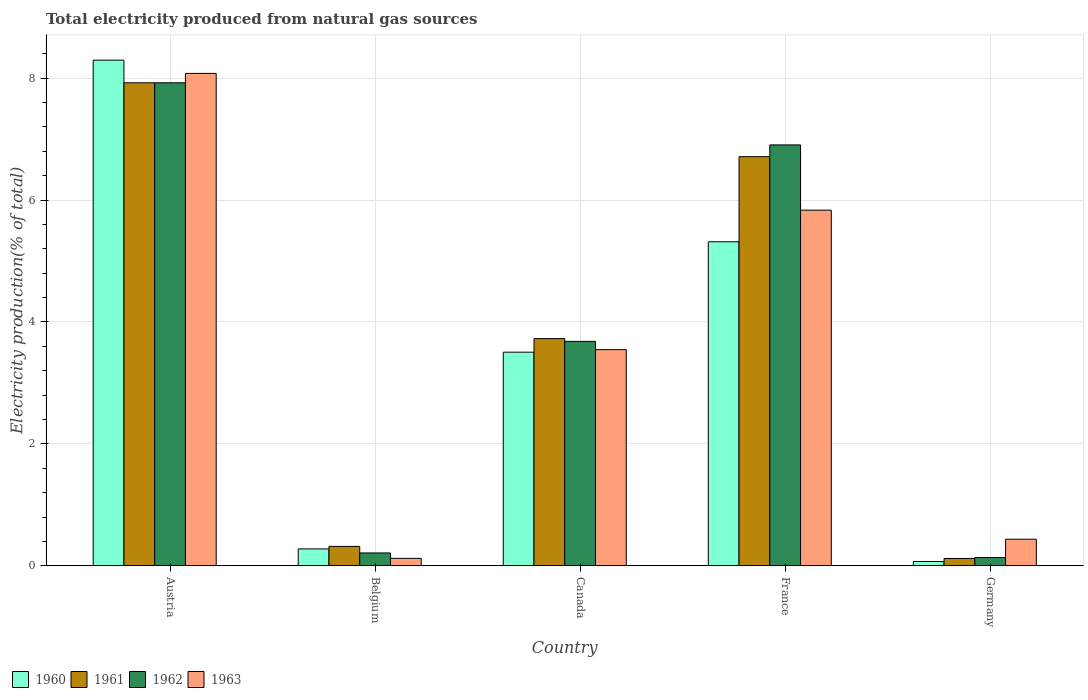How many groups of bars are there?
Offer a terse response. 5. Are the number of bars on each tick of the X-axis equal?
Offer a terse response. Yes. What is the label of the 4th group of bars from the left?
Your response must be concise. France. What is the total electricity produced in 1962 in Austria?
Your response must be concise. 7.92. Across all countries, what is the maximum total electricity produced in 1961?
Offer a terse response. 7.92. Across all countries, what is the minimum total electricity produced in 1962?
Your answer should be very brief. 0.14. In which country was the total electricity produced in 1961 minimum?
Offer a very short reply. Germany. What is the total total electricity produced in 1963 in the graph?
Provide a short and direct response. 18.02. What is the difference between the total electricity produced in 1963 in Canada and that in Germany?
Keep it short and to the point. 3.11. What is the difference between the total electricity produced in 1963 in Austria and the total electricity produced in 1960 in Canada?
Your answer should be compact. 4.57. What is the average total electricity produced in 1961 per country?
Make the answer very short. 3.76. What is the difference between the total electricity produced of/in 1963 and total electricity produced of/in 1962 in Austria?
Give a very brief answer. 0.15. In how many countries, is the total electricity produced in 1962 greater than 3.2 %?
Ensure brevity in your answer.  3. What is the ratio of the total electricity produced in 1961 in France to that in Germany?
Offer a terse response. 55.79. Is the total electricity produced in 1962 in Canada less than that in Germany?
Give a very brief answer. No. Is the difference between the total electricity produced in 1963 in Austria and Belgium greater than the difference between the total electricity produced in 1962 in Austria and Belgium?
Keep it short and to the point. Yes. What is the difference between the highest and the second highest total electricity produced in 1962?
Your answer should be very brief. -3.22. What is the difference between the highest and the lowest total electricity produced in 1961?
Provide a succinct answer. 7.8. In how many countries, is the total electricity produced in 1962 greater than the average total electricity produced in 1962 taken over all countries?
Provide a succinct answer. 2. Is it the case that in every country, the sum of the total electricity produced in 1961 and total electricity produced in 1963 is greater than the sum of total electricity produced in 1962 and total electricity produced in 1960?
Provide a succinct answer. No. Is it the case that in every country, the sum of the total electricity produced in 1961 and total electricity produced in 1960 is greater than the total electricity produced in 1963?
Provide a succinct answer. No. How many bars are there?
Offer a very short reply. 20. How many countries are there in the graph?
Make the answer very short. 5. Are the values on the major ticks of Y-axis written in scientific E-notation?
Offer a very short reply. No. Does the graph contain any zero values?
Ensure brevity in your answer.  No. How many legend labels are there?
Make the answer very short. 4. How are the legend labels stacked?
Your answer should be compact. Horizontal. What is the title of the graph?
Ensure brevity in your answer.  Total electricity produced from natural gas sources. Does "1986" appear as one of the legend labels in the graph?
Your answer should be very brief. No. What is the label or title of the Y-axis?
Make the answer very short. Electricity production(% of total). What is the Electricity production(% of total) in 1960 in Austria?
Keep it short and to the point. 8.3. What is the Electricity production(% of total) of 1961 in Austria?
Give a very brief answer. 7.92. What is the Electricity production(% of total) of 1962 in Austria?
Offer a very short reply. 7.92. What is the Electricity production(% of total) in 1963 in Austria?
Provide a succinct answer. 8.08. What is the Electricity production(% of total) of 1960 in Belgium?
Make the answer very short. 0.28. What is the Electricity production(% of total) of 1961 in Belgium?
Provide a short and direct response. 0.32. What is the Electricity production(% of total) in 1962 in Belgium?
Give a very brief answer. 0.21. What is the Electricity production(% of total) of 1963 in Belgium?
Your answer should be very brief. 0.12. What is the Electricity production(% of total) in 1960 in Canada?
Make the answer very short. 3.5. What is the Electricity production(% of total) of 1961 in Canada?
Offer a very short reply. 3.73. What is the Electricity production(% of total) in 1962 in Canada?
Make the answer very short. 3.68. What is the Electricity production(% of total) in 1963 in Canada?
Your response must be concise. 3.55. What is the Electricity production(% of total) of 1960 in France?
Your response must be concise. 5.32. What is the Electricity production(% of total) of 1961 in France?
Your response must be concise. 6.71. What is the Electricity production(% of total) of 1962 in France?
Give a very brief answer. 6.91. What is the Electricity production(% of total) in 1963 in France?
Your answer should be compact. 5.83. What is the Electricity production(% of total) of 1960 in Germany?
Your response must be concise. 0.07. What is the Electricity production(% of total) of 1961 in Germany?
Keep it short and to the point. 0.12. What is the Electricity production(% of total) in 1962 in Germany?
Your answer should be compact. 0.14. What is the Electricity production(% of total) of 1963 in Germany?
Make the answer very short. 0.44. Across all countries, what is the maximum Electricity production(% of total) of 1960?
Make the answer very short. 8.3. Across all countries, what is the maximum Electricity production(% of total) of 1961?
Provide a succinct answer. 7.92. Across all countries, what is the maximum Electricity production(% of total) of 1962?
Provide a succinct answer. 7.92. Across all countries, what is the maximum Electricity production(% of total) in 1963?
Your answer should be compact. 8.08. Across all countries, what is the minimum Electricity production(% of total) in 1960?
Provide a succinct answer. 0.07. Across all countries, what is the minimum Electricity production(% of total) of 1961?
Your response must be concise. 0.12. Across all countries, what is the minimum Electricity production(% of total) of 1962?
Keep it short and to the point. 0.14. Across all countries, what is the minimum Electricity production(% of total) in 1963?
Keep it short and to the point. 0.12. What is the total Electricity production(% of total) in 1960 in the graph?
Ensure brevity in your answer.  17.46. What is the total Electricity production(% of total) of 1961 in the graph?
Provide a short and direct response. 18.8. What is the total Electricity production(% of total) in 1962 in the graph?
Provide a short and direct response. 18.86. What is the total Electricity production(% of total) of 1963 in the graph?
Offer a terse response. 18.02. What is the difference between the Electricity production(% of total) in 1960 in Austria and that in Belgium?
Provide a succinct answer. 8.02. What is the difference between the Electricity production(% of total) of 1961 in Austria and that in Belgium?
Your answer should be very brief. 7.61. What is the difference between the Electricity production(% of total) in 1962 in Austria and that in Belgium?
Your response must be concise. 7.71. What is the difference between the Electricity production(% of total) in 1963 in Austria and that in Belgium?
Provide a short and direct response. 7.96. What is the difference between the Electricity production(% of total) in 1960 in Austria and that in Canada?
Keep it short and to the point. 4.79. What is the difference between the Electricity production(% of total) of 1961 in Austria and that in Canada?
Make the answer very short. 4.2. What is the difference between the Electricity production(% of total) of 1962 in Austria and that in Canada?
Your answer should be compact. 4.24. What is the difference between the Electricity production(% of total) of 1963 in Austria and that in Canada?
Your answer should be very brief. 4.53. What is the difference between the Electricity production(% of total) of 1960 in Austria and that in France?
Make the answer very short. 2.98. What is the difference between the Electricity production(% of total) in 1961 in Austria and that in France?
Offer a very short reply. 1.21. What is the difference between the Electricity production(% of total) in 1962 in Austria and that in France?
Make the answer very short. 1.02. What is the difference between the Electricity production(% of total) of 1963 in Austria and that in France?
Provide a succinct answer. 2.24. What is the difference between the Electricity production(% of total) of 1960 in Austria and that in Germany?
Provide a succinct answer. 8.23. What is the difference between the Electricity production(% of total) of 1961 in Austria and that in Germany?
Your answer should be very brief. 7.8. What is the difference between the Electricity production(% of total) in 1962 in Austria and that in Germany?
Offer a very short reply. 7.79. What is the difference between the Electricity production(% of total) of 1963 in Austria and that in Germany?
Keep it short and to the point. 7.64. What is the difference between the Electricity production(% of total) of 1960 in Belgium and that in Canada?
Make the answer very short. -3.23. What is the difference between the Electricity production(% of total) of 1961 in Belgium and that in Canada?
Give a very brief answer. -3.41. What is the difference between the Electricity production(% of total) of 1962 in Belgium and that in Canada?
Keep it short and to the point. -3.47. What is the difference between the Electricity production(% of total) in 1963 in Belgium and that in Canada?
Ensure brevity in your answer.  -3.42. What is the difference between the Electricity production(% of total) of 1960 in Belgium and that in France?
Give a very brief answer. -5.04. What is the difference between the Electricity production(% of total) of 1961 in Belgium and that in France?
Give a very brief answer. -6.39. What is the difference between the Electricity production(% of total) in 1962 in Belgium and that in France?
Offer a terse response. -6.69. What is the difference between the Electricity production(% of total) of 1963 in Belgium and that in France?
Provide a short and direct response. -5.71. What is the difference between the Electricity production(% of total) in 1960 in Belgium and that in Germany?
Offer a terse response. 0.21. What is the difference between the Electricity production(% of total) of 1961 in Belgium and that in Germany?
Keep it short and to the point. 0.2. What is the difference between the Electricity production(% of total) in 1962 in Belgium and that in Germany?
Your answer should be compact. 0.07. What is the difference between the Electricity production(% of total) of 1963 in Belgium and that in Germany?
Your answer should be very brief. -0.31. What is the difference between the Electricity production(% of total) in 1960 in Canada and that in France?
Your answer should be compact. -1.81. What is the difference between the Electricity production(% of total) in 1961 in Canada and that in France?
Your response must be concise. -2.99. What is the difference between the Electricity production(% of total) of 1962 in Canada and that in France?
Provide a short and direct response. -3.22. What is the difference between the Electricity production(% of total) in 1963 in Canada and that in France?
Keep it short and to the point. -2.29. What is the difference between the Electricity production(% of total) of 1960 in Canada and that in Germany?
Your answer should be compact. 3.43. What is the difference between the Electricity production(% of total) in 1961 in Canada and that in Germany?
Give a very brief answer. 3.61. What is the difference between the Electricity production(% of total) of 1962 in Canada and that in Germany?
Keep it short and to the point. 3.55. What is the difference between the Electricity production(% of total) of 1963 in Canada and that in Germany?
Your response must be concise. 3.11. What is the difference between the Electricity production(% of total) in 1960 in France and that in Germany?
Offer a very short reply. 5.25. What is the difference between the Electricity production(% of total) in 1961 in France and that in Germany?
Give a very brief answer. 6.59. What is the difference between the Electricity production(% of total) of 1962 in France and that in Germany?
Your answer should be compact. 6.77. What is the difference between the Electricity production(% of total) in 1963 in France and that in Germany?
Offer a terse response. 5.4. What is the difference between the Electricity production(% of total) of 1960 in Austria and the Electricity production(% of total) of 1961 in Belgium?
Your answer should be compact. 7.98. What is the difference between the Electricity production(% of total) in 1960 in Austria and the Electricity production(% of total) in 1962 in Belgium?
Your answer should be very brief. 8.08. What is the difference between the Electricity production(% of total) in 1960 in Austria and the Electricity production(% of total) in 1963 in Belgium?
Your answer should be very brief. 8.17. What is the difference between the Electricity production(% of total) of 1961 in Austria and the Electricity production(% of total) of 1962 in Belgium?
Your answer should be very brief. 7.71. What is the difference between the Electricity production(% of total) of 1961 in Austria and the Electricity production(% of total) of 1963 in Belgium?
Ensure brevity in your answer.  7.8. What is the difference between the Electricity production(% of total) of 1962 in Austria and the Electricity production(% of total) of 1963 in Belgium?
Your response must be concise. 7.8. What is the difference between the Electricity production(% of total) of 1960 in Austria and the Electricity production(% of total) of 1961 in Canada?
Give a very brief answer. 4.57. What is the difference between the Electricity production(% of total) of 1960 in Austria and the Electricity production(% of total) of 1962 in Canada?
Ensure brevity in your answer.  4.61. What is the difference between the Electricity production(% of total) of 1960 in Austria and the Electricity production(% of total) of 1963 in Canada?
Your answer should be very brief. 4.75. What is the difference between the Electricity production(% of total) of 1961 in Austria and the Electricity production(% of total) of 1962 in Canada?
Ensure brevity in your answer.  4.24. What is the difference between the Electricity production(% of total) in 1961 in Austria and the Electricity production(% of total) in 1963 in Canada?
Your answer should be compact. 4.38. What is the difference between the Electricity production(% of total) of 1962 in Austria and the Electricity production(% of total) of 1963 in Canada?
Your answer should be compact. 4.38. What is the difference between the Electricity production(% of total) in 1960 in Austria and the Electricity production(% of total) in 1961 in France?
Your answer should be very brief. 1.58. What is the difference between the Electricity production(% of total) of 1960 in Austria and the Electricity production(% of total) of 1962 in France?
Offer a terse response. 1.39. What is the difference between the Electricity production(% of total) in 1960 in Austria and the Electricity production(% of total) in 1963 in France?
Make the answer very short. 2.46. What is the difference between the Electricity production(% of total) in 1961 in Austria and the Electricity production(% of total) in 1963 in France?
Offer a very short reply. 2.09. What is the difference between the Electricity production(% of total) of 1962 in Austria and the Electricity production(% of total) of 1963 in France?
Your response must be concise. 2.09. What is the difference between the Electricity production(% of total) in 1960 in Austria and the Electricity production(% of total) in 1961 in Germany?
Provide a succinct answer. 8.18. What is the difference between the Electricity production(% of total) in 1960 in Austria and the Electricity production(% of total) in 1962 in Germany?
Your response must be concise. 8.16. What is the difference between the Electricity production(% of total) of 1960 in Austria and the Electricity production(% of total) of 1963 in Germany?
Offer a very short reply. 7.86. What is the difference between the Electricity production(% of total) of 1961 in Austria and the Electricity production(% of total) of 1962 in Germany?
Your answer should be very brief. 7.79. What is the difference between the Electricity production(% of total) of 1961 in Austria and the Electricity production(% of total) of 1963 in Germany?
Your answer should be compact. 7.49. What is the difference between the Electricity production(% of total) in 1962 in Austria and the Electricity production(% of total) in 1963 in Germany?
Provide a succinct answer. 7.49. What is the difference between the Electricity production(% of total) of 1960 in Belgium and the Electricity production(% of total) of 1961 in Canada?
Your answer should be very brief. -3.45. What is the difference between the Electricity production(% of total) of 1960 in Belgium and the Electricity production(% of total) of 1962 in Canada?
Keep it short and to the point. -3.4. What is the difference between the Electricity production(% of total) of 1960 in Belgium and the Electricity production(% of total) of 1963 in Canada?
Ensure brevity in your answer.  -3.27. What is the difference between the Electricity production(% of total) in 1961 in Belgium and the Electricity production(% of total) in 1962 in Canada?
Offer a very short reply. -3.36. What is the difference between the Electricity production(% of total) in 1961 in Belgium and the Electricity production(% of total) in 1963 in Canada?
Give a very brief answer. -3.23. What is the difference between the Electricity production(% of total) in 1962 in Belgium and the Electricity production(% of total) in 1963 in Canada?
Give a very brief answer. -3.34. What is the difference between the Electricity production(% of total) of 1960 in Belgium and the Electricity production(% of total) of 1961 in France?
Ensure brevity in your answer.  -6.43. What is the difference between the Electricity production(% of total) in 1960 in Belgium and the Electricity production(% of total) in 1962 in France?
Offer a terse response. -6.63. What is the difference between the Electricity production(% of total) of 1960 in Belgium and the Electricity production(% of total) of 1963 in France?
Your answer should be compact. -5.56. What is the difference between the Electricity production(% of total) in 1961 in Belgium and the Electricity production(% of total) in 1962 in France?
Offer a very short reply. -6.59. What is the difference between the Electricity production(% of total) in 1961 in Belgium and the Electricity production(% of total) in 1963 in France?
Give a very brief answer. -5.52. What is the difference between the Electricity production(% of total) in 1962 in Belgium and the Electricity production(% of total) in 1963 in France?
Provide a short and direct response. -5.62. What is the difference between the Electricity production(% of total) in 1960 in Belgium and the Electricity production(% of total) in 1961 in Germany?
Offer a terse response. 0.16. What is the difference between the Electricity production(% of total) of 1960 in Belgium and the Electricity production(% of total) of 1962 in Germany?
Provide a short and direct response. 0.14. What is the difference between the Electricity production(% of total) of 1960 in Belgium and the Electricity production(% of total) of 1963 in Germany?
Your answer should be very brief. -0.16. What is the difference between the Electricity production(% of total) of 1961 in Belgium and the Electricity production(% of total) of 1962 in Germany?
Keep it short and to the point. 0.18. What is the difference between the Electricity production(% of total) of 1961 in Belgium and the Electricity production(% of total) of 1963 in Germany?
Your response must be concise. -0.12. What is the difference between the Electricity production(% of total) of 1962 in Belgium and the Electricity production(% of total) of 1963 in Germany?
Ensure brevity in your answer.  -0.23. What is the difference between the Electricity production(% of total) of 1960 in Canada and the Electricity production(% of total) of 1961 in France?
Give a very brief answer. -3.21. What is the difference between the Electricity production(% of total) in 1960 in Canada and the Electricity production(% of total) in 1962 in France?
Provide a succinct answer. -3.4. What is the difference between the Electricity production(% of total) of 1960 in Canada and the Electricity production(% of total) of 1963 in France?
Give a very brief answer. -2.33. What is the difference between the Electricity production(% of total) in 1961 in Canada and the Electricity production(% of total) in 1962 in France?
Offer a very short reply. -3.18. What is the difference between the Electricity production(% of total) in 1961 in Canada and the Electricity production(% of total) in 1963 in France?
Your response must be concise. -2.11. What is the difference between the Electricity production(% of total) of 1962 in Canada and the Electricity production(% of total) of 1963 in France?
Provide a succinct answer. -2.15. What is the difference between the Electricity production(% of total) of 1960 in Canada and the Electricity production(% of total) of 1961 in Germany?
Provide a short and direct response. 3.38. What is the difference between the Electricity production(% of total) of 1960 in Canada and the Electricity production(% of total) of 1962 in Germany?
Your answer should be compact. 3.37. What is the difference between the Electricity production(% of total) in 1960 in Canada and the Electricity production(% of total) in 1963 in Germany?
Your response must be concise. 3.07. What is the difference between the Electricity production(% of total) of 1961 in Canada and the Electricity production(% of total) of 1962 in Germany?
Keep it short and to the point. 3.59. What is the difference between the Electricity production(% of total) of 1961 in Canada and the Electricity production(% of total) of 1963 in Germany?
Provide a succinct answer. 3.29. What is the difference between the Electricity production(% of total) in 1962 in Canada and the Electricity production(% of total) in 1963 in Germany?
Provide a succinct answer. 3.25. What is the difference between the Electricity production(% of total) of 1960 in France and the Electricity production(% of total) of 1961 in Germany?
Offer a terse response. 5.2. What is the difference between the Electricity production(% of total) of 1960 in France and the Electricity production(% of total) of 1962 in Germany?
Provide a short and direct response. 5.18. What is the difference between the Electricity production(% of total) of 1960 in France and the Electricity production(% of total) of 1963 in Germany?
Your response must be concise. 4.88. What is the difference between the Electricity production(% of total) in 1961 in France and the Electricity production(% of total) in 1962 in Germany?
Ensure brevity in your answer.  6.58. What is the difference between the Electricity production(% of total) in 1961 in France and the Electricity production(% of total) in 1963 in Germany?
Offer a terse response. 6.28. What is the difference between the Electricity production(% of total) in 1962 in France and the Electricity production(% of total) in 1963 in Germany?
Make the answer very short. 6.47. What is the average Electricity production(% of total) of 1960 per country?
Keep it short and to the point. 3.49. What is the average Electricity production(% of total) in 1961 per country?
Offer a terse response. 3.76. What is the average Electricity production(% of total) of 1962 per country?
Your answer should be compact. 3.77. What is the average Electricity production(% of total) of 1963 per country?
Offer a very short reply. 3.6. What is the difference between the Electricity production(% of total) in 1960 and Electricity production(% of total) in 1961 in Austria?
Provide a succinct answer. 0.37. What is the difference between the Electricity production(% of total) of 1960 and Electricity production(% of total) of 1962 in Austria?
Keep it short and to the point. 0.37. What is the difference between the Electricity production(% of total) of 1960 and Electricity production(% of total) of 1963 in Austria?
Ensure brevity in your answer.  0.22. What is the difference between the Electricity production(% of total) of 1961 and Electricity production(% of total) of 1963 in Austria?
Provide a succinct answer. -0.15. What is the difference between the Electricity production(% of total) in 1962 and Electricity production(% of total) in 1963 in Austria?
Provide a short and direct response. -0.15. What is the difference between the Electricity production(% of total) in 1960 and Electricity production(% of total) in 1961 in Belgium?
Your answer should be very brief. -0.04. What is the difference between the Electricity production(% of total) in 1960 and Electricity production(% of total) in 1962 in Belgium?
Give a very brief answer. 0.07. What is the difference between the Electricity production(% of total) of 1960 and Electricity production(% of total) of 1963 in Belgium?
Make the answer very short. 0.15. What is the difference between the Electricity production(% of total) of 1961 and Electricity production(% of total) of 1962 in Belgium?
Offer a terse response. 0.11. What is the difference between the Electricity production(% of total) of 1961 and Electricity production(% of total) of 1963 in Belgium?
Offer a terse response. 0.2. What is the difference between the Electricity production(% of total) in 1962 and Electricity production(% of total) in 1963 in Belgium?
Keep it short and to the point. 0.09. What is the difference between the Electricity production(% of total) of 1960 and Electricity production(% of total) of 1961 in Canada?
Give a very brief answer. -0.22. What is the difference between the Electricity production(% of total) of 1960 and Electricity production(% of total) of 1962 in Canada?
Offer a very short reply. -0.18. What is the difference between the Electricity production(% of total) of 1960 and Electricity production(% of total) of 1963 in Canada?
Your answer should be compact. -0.04. What is the difference between the Electricity production(% of total) in 1961 and Electricity production(% of total) in 1962 in Canada?
Make the answer very short. 0.05. What is the difference between the Electricity production(% of total) in 1961 and Electricity production(% of total) in 1963 in Canada?
Ensure brevity in your answer.  0.18. What is the difference between the Electricity production(% of total) in 1962 and Electricity production(% of total) in 1963 in Canada?
Offer a very short reply. 0.14. What is the difference between the Electricity production(% of total) in 1960 and Electricity production(% of total) in 1961 in France?
Provide a succinct answer. -1.4. What is the difference between the Electricity production(% of total) in 1960 and Electricity production(% of total) in 1962 in France?
Give a very brief answer. -1.59. What is the difference between the Electricity production(% of total) of 1960 and Electricity production(% of total) of 1963 in France?
Give a very brief answer. -0.52. What is the difference between the Electricity production(% of total) in 1961 and Electricity production(% of total) in 1962 in France?
Ensure brevity in your answer.  -0.19. What is the difference between the Electricity production(% of total) in 1961 and Electricity production(% of total) in 1963 in France?
Keep it short and to the point. 0.88. What is the difference between the Electricity production(% of total) of 1962 and Electricity production(% of total) of 1963 in France?
Your answer should be very brief. 1.07. What is the difference between the Electricity production(% of total) of 1960 and Electricity production(% of total) of 1962 in Germany?
Make the answer very short. -0.07. What is the difference between the Electricity production(% of total) of 1960 and Electricity production(% of total) of 1963 in Germany?
Ensure brevity in your answer.  -0.37. What is the difference between the Electricity production(% of total) of 1961 and Electricity production(% of total) of 1962 in Germany?
Make the answer very short. -0.02. What is the difference between the Electricity production(% of total) of 1961 and Electricity production(% of total) of 1963 in Germany?
Ensure brevity in your answer.  -0.32. What is the difference between the Electricity production(% of total) of 1962 and Electricity production(% of total) of 1963 in Germany?
Offer a terse response. -0.3. What is the ratio of the Electricity production(% of total) in 1960 in Austria to that in Belgium?
Keep it short and to the point. 29.93. What is the ratio of the Electricity production(% of total) of 1961 in Austria to that in Belgium?
Ensure brevity in your answer.  24.9. What is the ratio of the Electricity production(% of total) in 1962 in Austria to that in Belgium?
Your response must be concise. 37.57. What is the ratio of the Electricity production(% of total) of 1963 in Austria to that in Belgium?
Make the answer very short. 66.07. What is the ratio of the Electricity production(% of total) of 1960 in Austria to that in Canada?
Provide a short and direct response. 2.37. What is the ratio of the Electricity production(% of total) in 1961 in Austria to that in Canada?
Make the answer very short. 2.13. What is the ratio of the Electricity production(% of total) in 1962 in Austria to that in Canada?
Keep it short and to the point. 2.15. What is the ratio of the Electricity production(% of total) of 1963 in Austria to that in Canada?
Offer a terse response. 2.28. What is the ratio of the Electricity production(% of total) in 1960 in Austria to that in France?
Make the answer very short. 1.56. What is the ratio of the Electricity production(% of total) in 1961 in Austria to that in France?
Provide a short and direct response. 1.18. What is the ratio of the Electricity production(% of total) of 1962 in Austria to that in France?
Provide a short and direct response. 1.15. What is the ratio of the Electricity production(% of total) of 1963 in Austria to that in France?
Offer a very short reply. 1.38. What is the ratio of the Electricity production(% of total) of 1960 in Austria to that in Germany?
Offer a very short reply. 118.01. What is the ratio of the Electricity production(% of total) of 1961 in Austria to that in Germany?
Offer a very short reply. 65.86. What is the ratio of the Electricity production(% of total) in 1962 in Austria to that in Germany?
Give a very brief answer. 58.17. What is the ratio of the Electricity production(% of total) in 1963 in Austria to that in Germany?
Offer a very short reply. 18.52. What is the ratio of the Electricity production(% of total) in 1960 in Belgium to that in Canada?
Your answer should be very brief. 0.08. What is the ratio of the Electricity production(% of total) of 1961 in Belgium to that in Canada?
Your answer should be compact. 0.09. What is the ratio of the Electricity production(% of total) in 1962 in Belgium to that in Canada?
Provide a succinct answer. 0.06. What is the ratio of the Electricity production(% of total) in 1963 in Belgium to that in Canada?
Offer a very short reply. 0.03. What is the ratio of the Electricity production(% of total) of 1960 in Belgium to that in France?
Ensure brevity in your answer.  0.05. What is the ratio of the Electricity production(% of total) in 1961 in Belgium to that in France?
Your answer should be compact. 0.05. What is the ratio of the Electricity production(% of total) of 1962 in Belgium to that in France?
Your answer should be very brief. 0.03. What is the ratio of the Electricity production(% of total) of 1963 in Belgium to that in France?
Keep it short and to the point. 0.02. What is the ratio of the Electricity production(% of total) in 1960 in Belgium to that in Germany?
Your answer should be very brief. 3.94. What is the ratio of the Electricity production(% of total) of 1961 in Belgium to that in Germany?
Ensure brevity in your answer.  2.64. What is the ratio of the Electricity production(% of total) in 1962 in Belgium to that in Germany?
Provide a short and direct response. 1.55. What is the ratio of the Electricity production(% of total) in 1963 in Belgium to that in Germany?
Keep it short and to the point. 0.28. What is the ratio of the Electricity production(% of total) of 1960 in Canada to that in France?
Your response must be concise. 0.66. What is the ratio of the Electricity production(% of total) of 1961 in Canada to that in France?
Offer a terse response. 0.56. What is the ratio of the Electricity production(% of total) of 1962 in Canada to that in France?
Provide a succinct answer. 0.53. What is the ratio of the Electricity production(% of total) in 1963 in Canada to that in France?
Give a very brief answer. 0.61. What is the ratio of the Electricity production(% of total) of 1960 in Canada to that in Germany?
Make the answer very short. 49.85. What is the ratio of the Electricity production(% of total) of 1961 in Canada to that in Germany?
Offer a terse response. 30.98. What is the ratio of the Electricity production(% of total) in 1962 in Canada to that in Germany?
Your response must be concise. 27.02. What is the ratio of the Electricity production(% of total) of 1963 in Canada to that in Germany?
Your response must be concise. 8.13. What is the ratio of the Electricity production(% of total) of 1960 in France to that in Germany?
Your response must be concise. 75.62. What is the ratio of the Electricity production(% of total) of 1961 in France to that in Germany?
Ensure brevity in your answer.  55.79. What is the ratio of the Electricity production(% of total) of 1962 in France to that in Germany?
Provide a succinct answer. 50.69. What is the ratio of the Electricity production(% of total) in 1963 in France to that in Germany?
Provide a short and direct response. 13.38. What is the difference between the highest and the second highest Electricity production(% of total) of 1960?
Give a very brief answer. 2.98. What is the difference between the highest and the second highest Electricity production(% of total) in 1961?
Provide a short and direct response. 1.21. What is the difference between the highest and the second highest Electricity production(% of total) of 1963?
Your response must be concise. 2.24. What is the difference between the highest and the lowest Electricity production(% of total) of 1960?
Keep it short and to the point. 8.23. What is the difference between the highest and the lowest Electricity production(% of total) of 1961?
Make the answer very short. 7.8. What is the difference between the highest and the lowest Electricity production(% of total) in 1962?
Your answer should be very brief. 7.79. What is the difference between the highest and the lowest Electricity production(% of total) of 1963?
Your answer should be very brief. 7.96. 